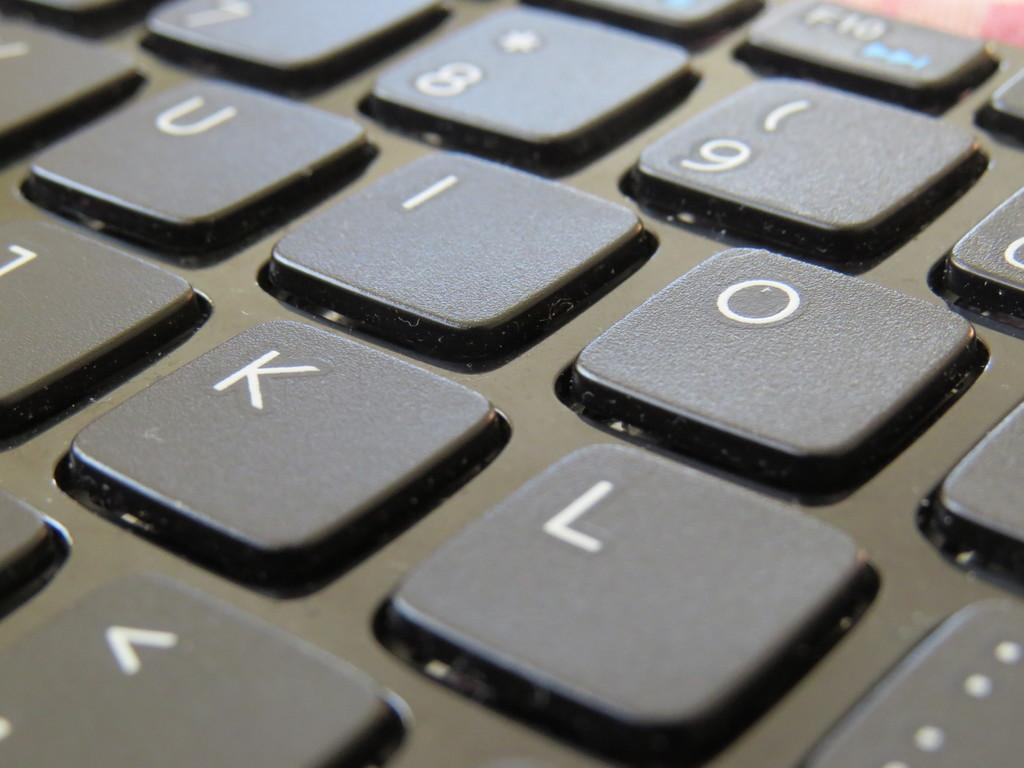What type of device is present in the image? The image contains a keyboard. What can be found on the keys of the keyboard? The keyboard has alphabets on its keys and number keys. What type of jar is visible on the keyboard in the image? There is no jar present on the keyboard in the image. What industry is represented by the keyboard in the image? The image does not represent any specific industry; it simply shows a keyboard with alphabets and number keys. 